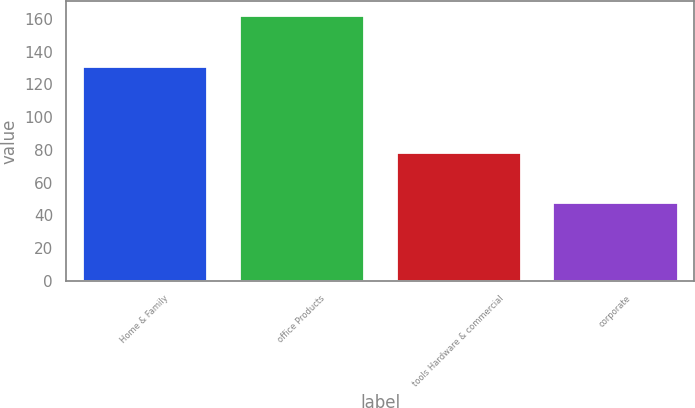Convert chart. <chart><loc_0><loc_0><loc_500><loc_500><bar_chart><fcel>Home & Family<fcel>office Products<fcel>tools Hardware & commercial<fcel>corporate<nl><fcel>131.1<fcel>162.7<fcel>78.9<fcel>48.2<nl></chart> 